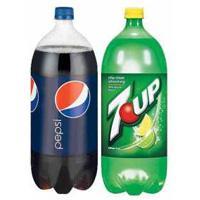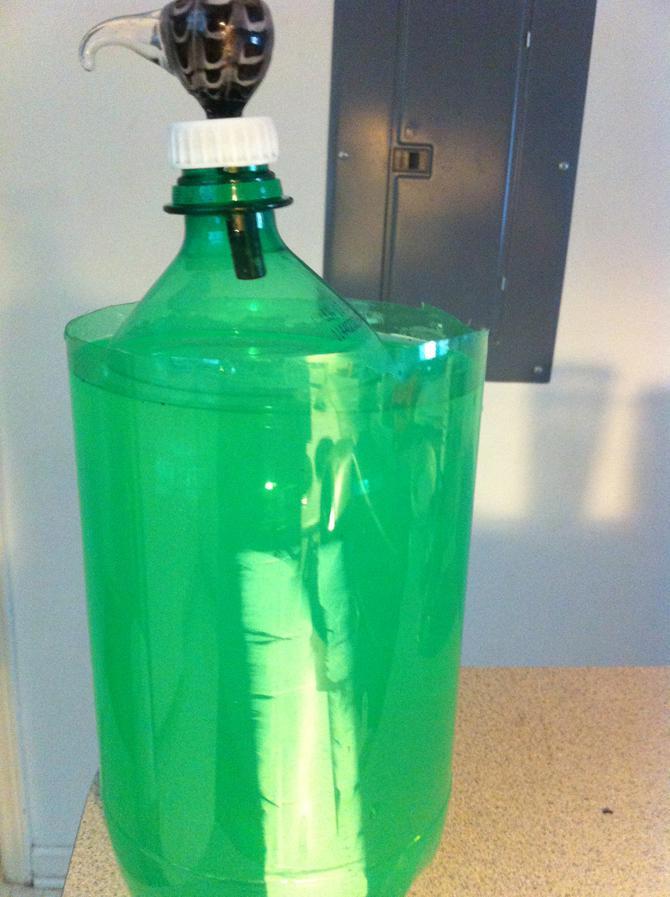The first image is the image on the left, the second image is the image on the right. For the images shown, is this caption "There are two glass full of the liquad from the soda bottle behind them." true? Answer yes or no. No. The first image is the image on the left, the second image is the image on the right. Assess this claim about the two images: "In the left image there are exactly two bottles with soda in them.". Correct or not? Answer yes or no. Yes. 